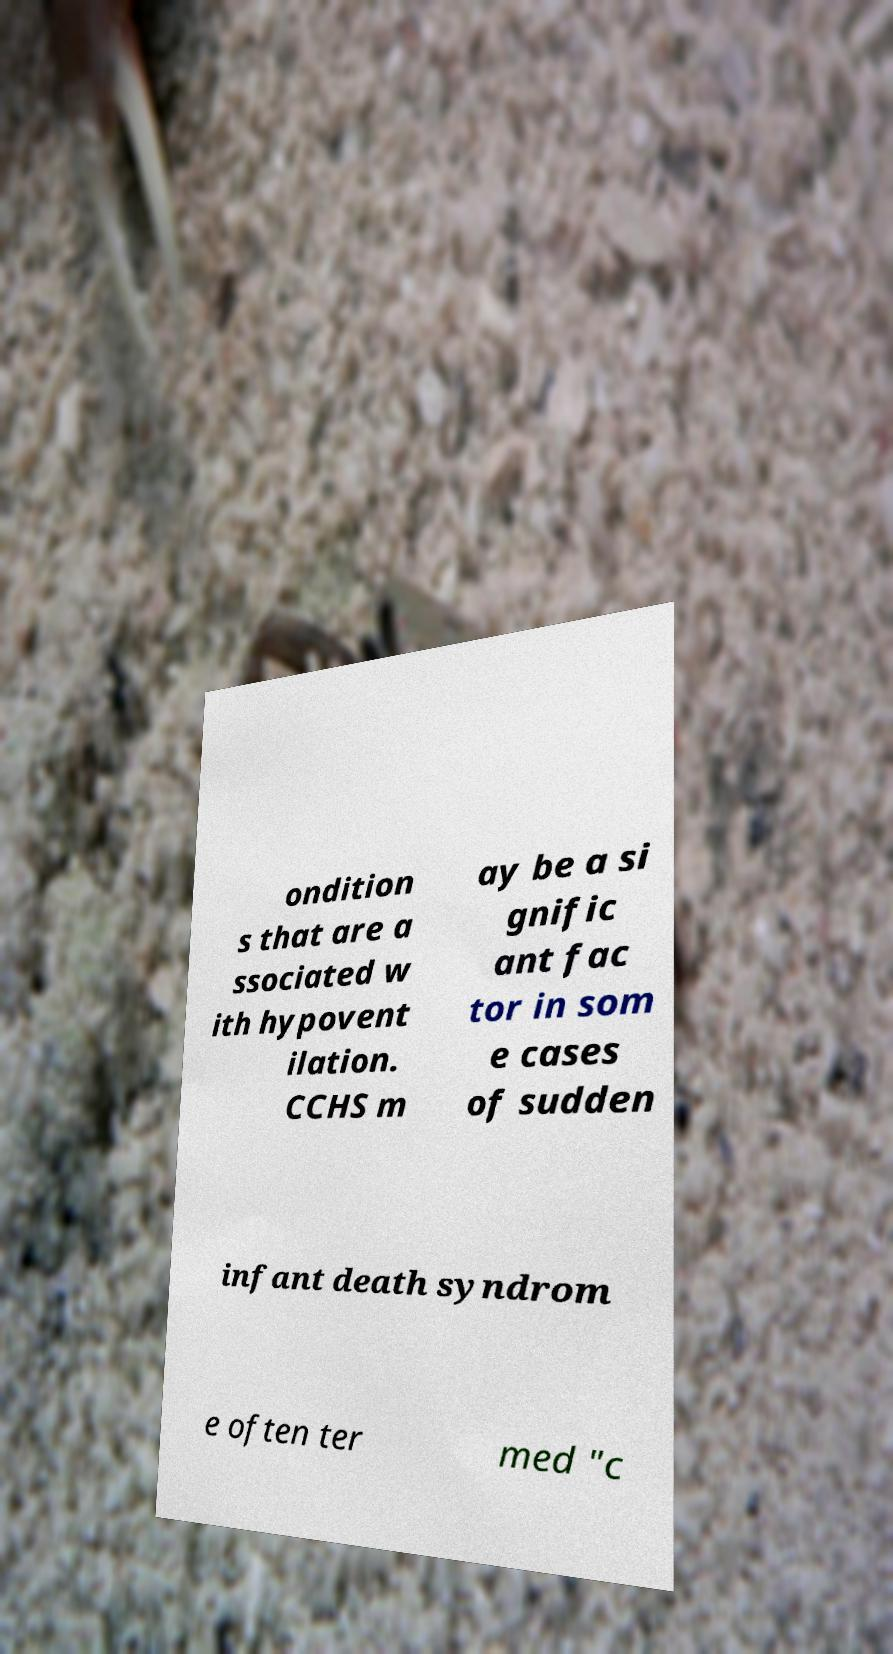Please read and relay the text visible in this image. What does it say? ondition s that are a ssociated w ith hypovent ilation. CCHS m ay be a si gnific ant fac tor in som e cases of sudden infant death syndrom e often ter med "c 